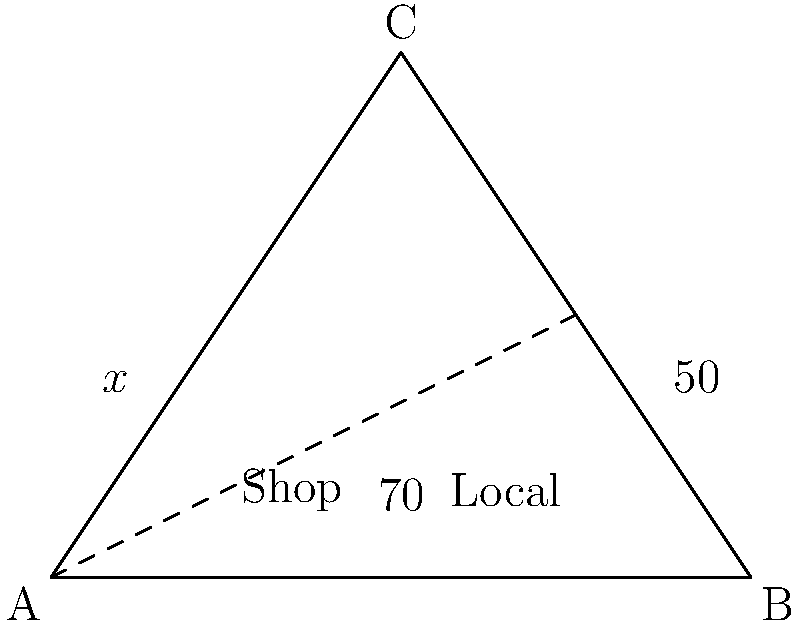A triangular "Shop Local" sign is designed with the following angles: the base angles are 70° and 50°, and the angle at the top is labeled as $x°$. What is the value of $x$? To find the value of $x$, we can follow these steps:

1) Recall that the sum of angles in a triangle is always 180°.

2) Let's set up an equation using this fact:
   $x° + 70° + 50° = 180°$

3) Simplify the left side of the equation:
   $x° + 120° = 180°$

4) Subtract 120° from both sides:
   $x° = 180° - 120°$

5) Simplify:
   $x° = 60°$

Therefore, the angle at the top of the "Shop Local" sign is 60°.
Answer: $60°$ 